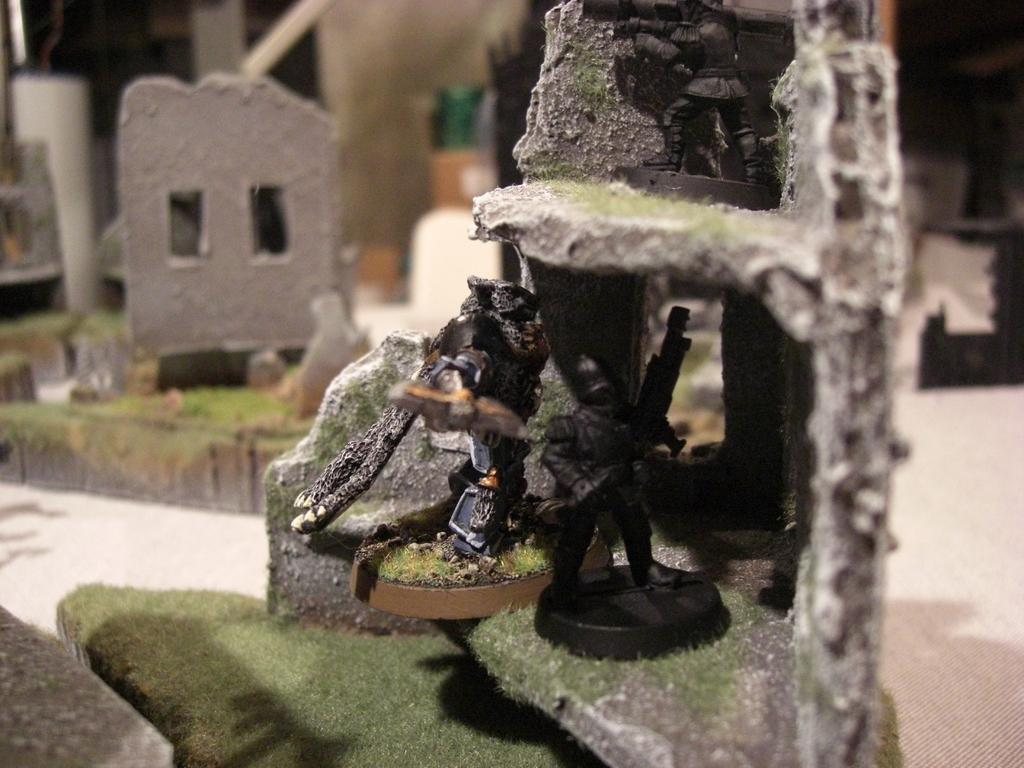What is located on the right side of the image? There is a shelf on the right side of the image. What is placed on the shelf? There is a sculpture on the shelf. Can you describe the background of the image? There are additional sculptures visible in the background of the image, along with a wall. What type of nail is being used to hang the sculpture in the image? There is no nail visible in the image, and the sculpture is not hanging but rather placed on the shelf. 